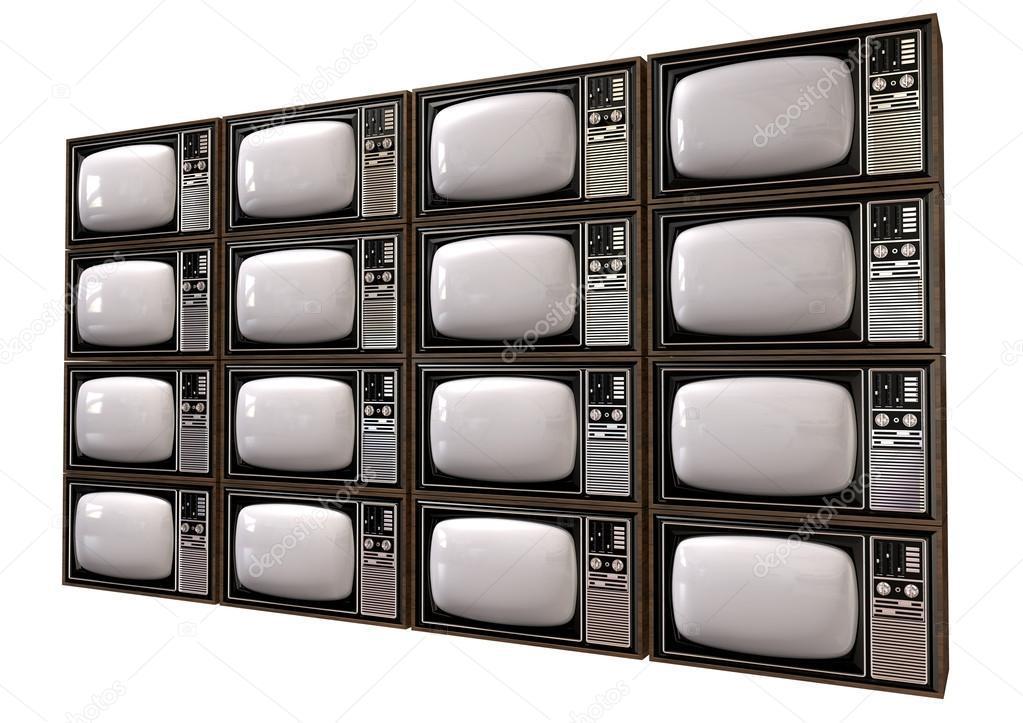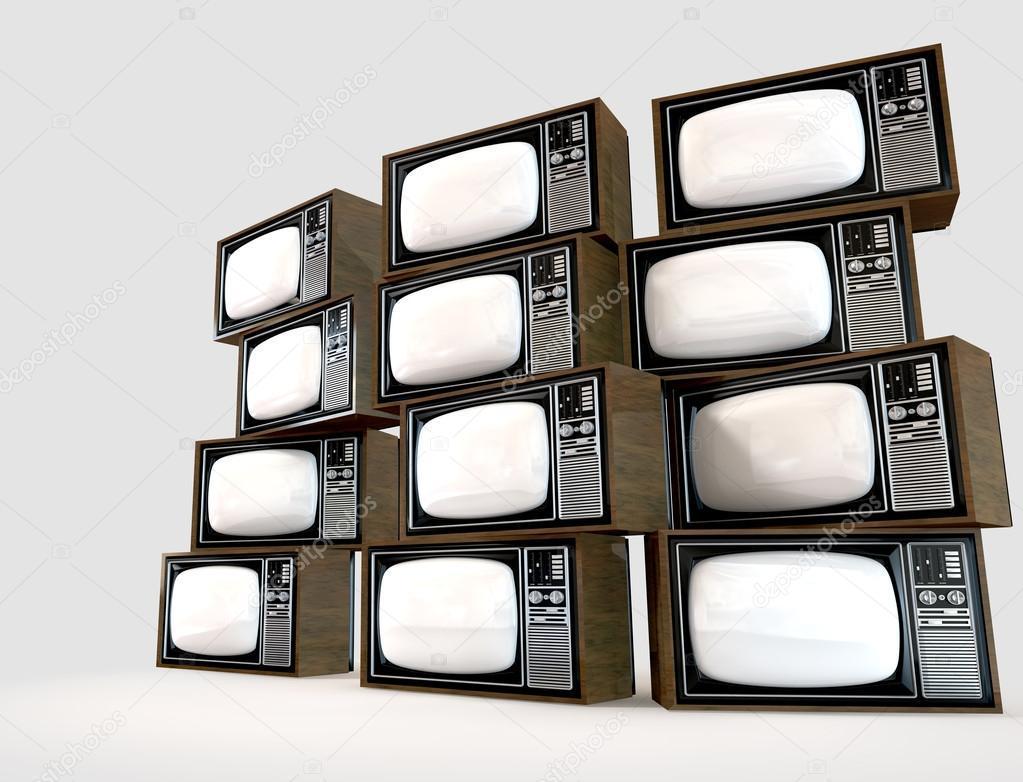The first image is the image on the left, the second image is the image on the right. Given the left and right images, does the statement "A sculpture resembling a lifeform is made from televisions in one of the images." hold true? Answer yes or no. No. The first image is the image on the left, the second image is the image on the right. Considering the images on both sides, is "Stacked cubes with screens take the shape of an animate object in one image." valid? Answer yes or no. No. 